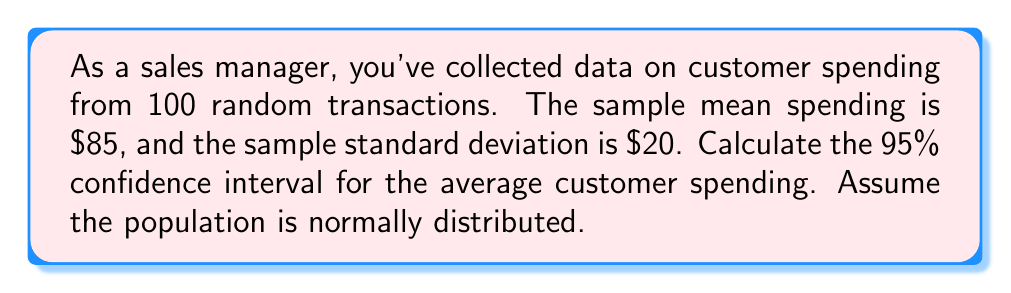Give your solution to this math problem. To calculate the confidence interval, we'll follow these steps:

1) The formula for the confidence interval is:

   $$\bar{x} \pm t_{\alpha/2} \cdot \frac{s}{\sqrt{n}}$$

   Where:
   $\bar{x}$ = sample mean
   $t_{\alpha/2}$ = t-value for desired confidence level
   $s$ = sample standard deviation
   $n$ = sample size

2) We know:
   $\bar{x} = 85$
   $s = 20$
   $n = 100$
   Confidence level = 95% (α = 0.05)

3) For a 95% confidence interval with 99 degrees of freedom (n-1), the t-value is approximately 1.984 (from t-distribution table).

4) Plugging into the formula:

   $$85 \pm 1.984 \cdot \frac{20}{\sqrt{100}}$$

5) Simplify:
   $$85 \pm 1.984 \cdot \frac{20}{10} = 85 \pm 1.984 \cdot 2 = 85 \pm 3.968$$

6) Therefore, the confidence interval is:

   $$[85 - 3.968, 85 + 3.968] = [81.032, 88.968]$$
Answer: $[81.03, 88.97] 